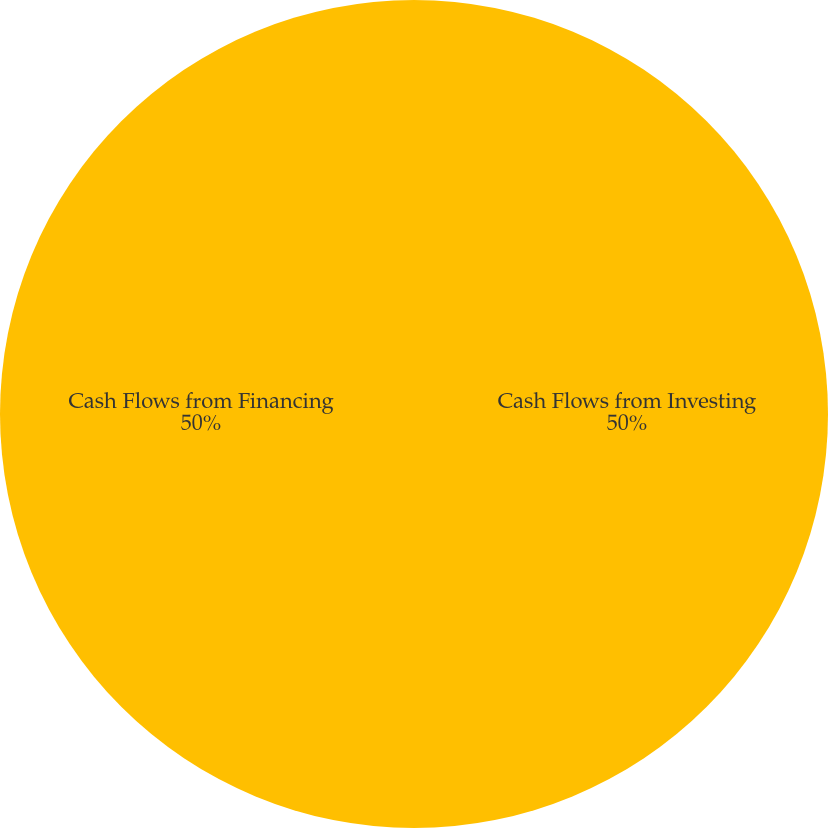Convert chart to OTSL. <chart><loc_0><loc_0><loc_500><loc_500><pie_chart><fcel>Cash Flows from Investing<fcel>Cash Flows from Financing<nl><fcel>50.0%<fcel>50.0%<nl></chart> 